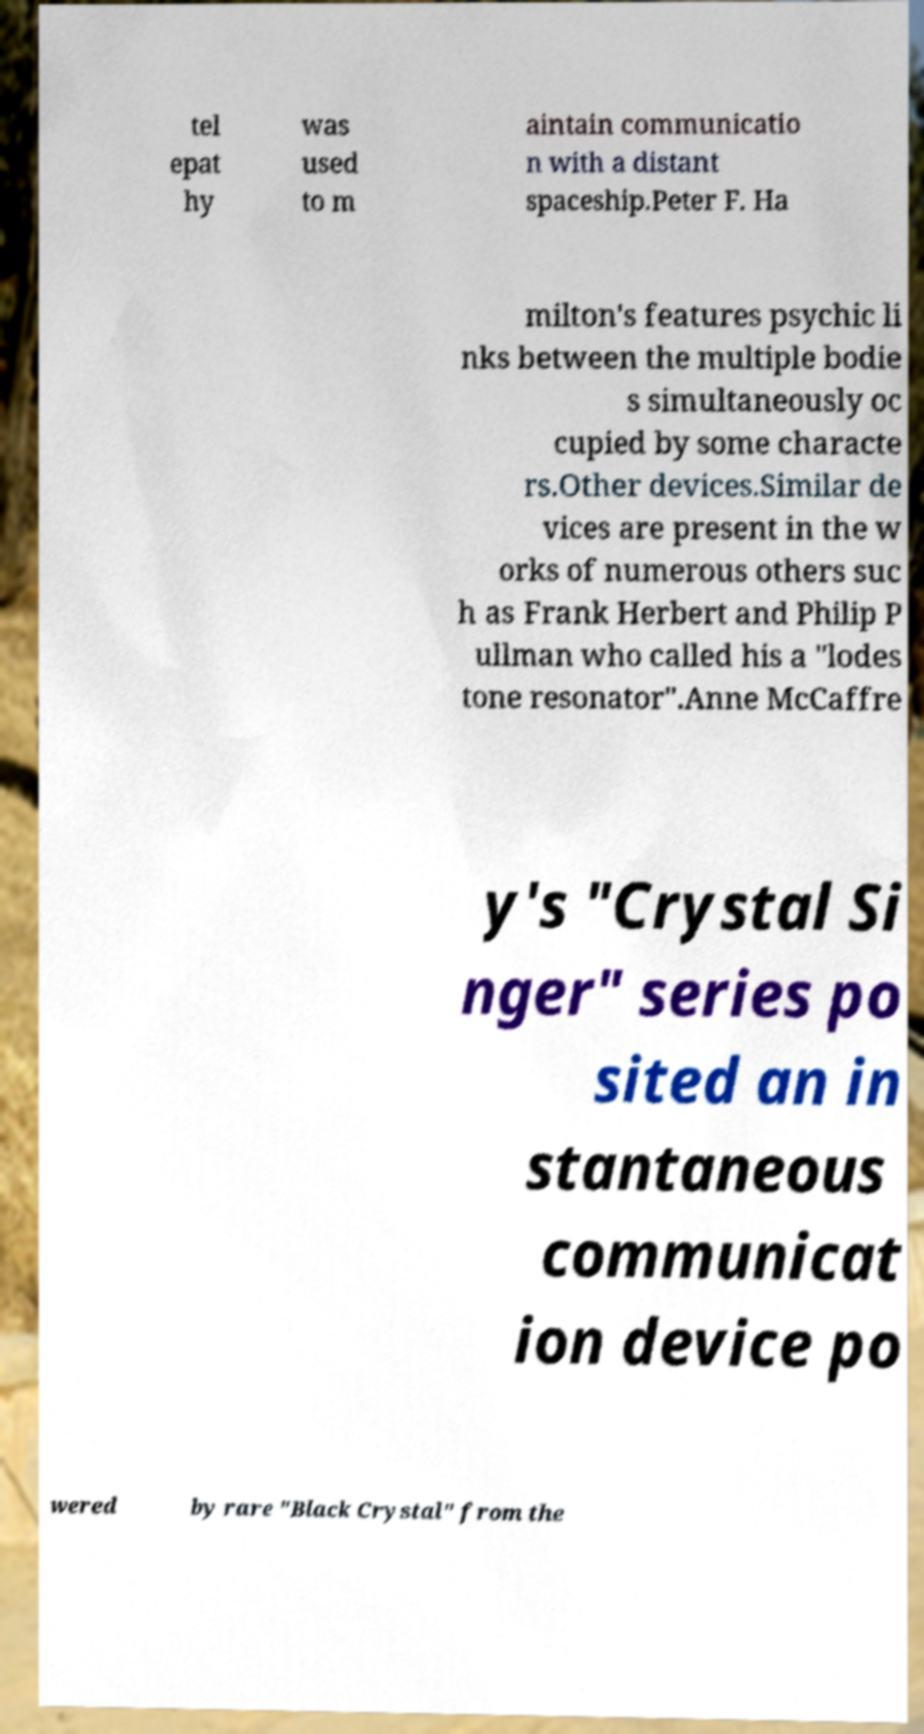There's text embedded in this image that I need extracted. Can you transcribe it verbatim? tel epat hy was used to m aintain communicatio n with a distant spaceship.Peter F. Ha milton's features psychic li nks between the multiple bodie s simultaneously oc cupied by some characte rs.Other devices.Similar de vices are present in the w orks of numerous others suc h as Frank Herbert and Philip P ullman who called his a "lodes tone resonator".Anne McCaffre y's "Crystal Si nger" series po sited an in stantaneous communicat ion device po wered by rare "Black Crystal" from the 